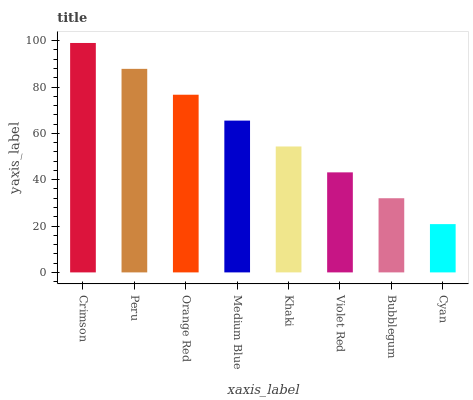Is Cyan the minimum?
Answer yes or no. Yes. Is Crimson the maximum?
Answer yes or no. Yes. Is Peru the minimum?
Answer yes or no. No. Is Peru the maximum?
Answer yes or no. No. Is Crimson greater than Peru?
Answer yes or no. Yes. Is Peru less than Crimson?
Answer yes or no. Yes. Is Peru greater than Crimson?
Answer yes or no. No. Is Crimson less than Peru?
Answer yes or no. No. Is Medium Blue the high median?
Answer yes or no. Yes. Is Khaki the low median?
Answer yes or no. Yes. Is Orange Red the high median?
Answer yes or no. No. Is Violet Red the low median?
Answer yes or no. No. 